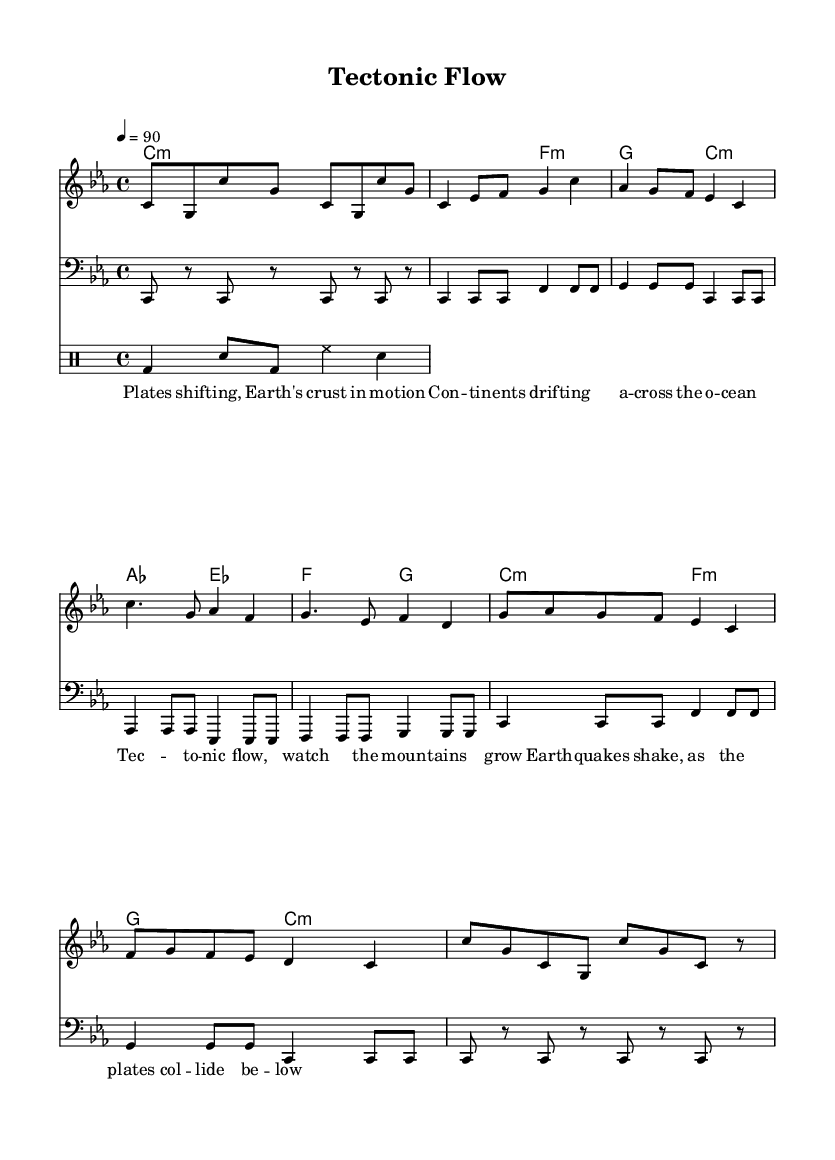What is the key signature of this music? The key signature is C minor, which has three flats (B, E, and A). It can be recognized from the initial part of the score.
Answer: C minor What is the time signature of this music? The time signature is 4/4, indicated at the beginning of the score. This means there are four beats in a measure, with each quarter note receiving one beat.
Answer: 4/4 What is the tempo marking of this music? The tempo marking is indicated as "4 = 90," meaning there are 90 beats per minute. This is shown at the start of the score.
Answer: 90 How many measures are in the melody section? By counting the number of distinct groups of notes within the melody line, there are a total of eight measures in the melody section.
Answer: 8 What is the primary theme of the lyrics? The primary theme revolves around geological processes and plate tectonics, as mentioned through terms like "plates shifting" and "tectonic flow." This is observed throughout the lyrics accompanying the melody.
Answer: Geological processes What are the instruments indicated in this arrangement? The arrangement features a melody staff (for vocals), a bass staff, and a drum staff, combining multiple musical elements suited for rap. This can be identified by the different types of staves in the score.
Answer: Melody, bass, drums What rhythmic pattern is used in the drum section? The drum pattern consists of a kick drum, snare, and hi-hat in a consistent alternating pattern, as shown in the drum staff section. Each symbol corresponds to the rhythm indicated.
Answer: Kick, snare, hi-hat 